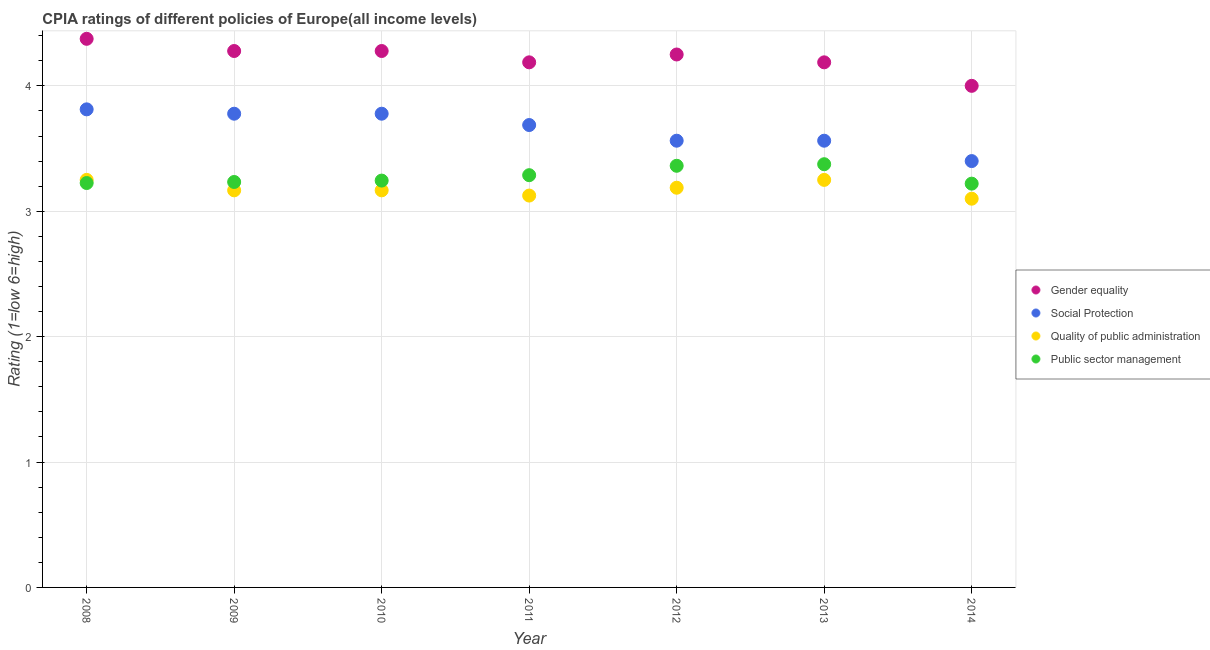How many different coloured dotlines are there?
Offer a very short reply. 4. Is the number of dotlines equal to the number of legend labels?
Offer a very short reply. Yes. What is the cpia rating of public sector management in 2008?
Keep it short and to the point. 3.23. What is the total cpia rating of quality of public administration in the graph?
Offer a terse response. 22.25. What is the difference between the cpia rating of social protection in 2010 and that in 2014?
Ensure brevity in your answer.  0.38. What is the difference between the cpia rating of public sector management in 2011 and the cpia rating of quality of public administration in 2014?
Keep it short and to the point. 0.19. What is the average cpia rating of gender equality per year?
Make the answer very short. 4.22. What is the ratio of the cpia rating of gender equality in 2008 to that in 2013?
Keep it short and to the point. 1.04. What is the difference between the highest and the second highest cpia rating of gender equality?
Ensure brevity in your answer.  0.1. What is the difference between the highest and the lowest cpia rating of quality of public administration?
Ensure brevity in your answer.  0.15. Is it the case that in every year, the sum of the cpia rating of quality of public administration and cpia rating of public sector management is greater than the sum of cpia rating of social protection and cpia rating of gender equality?
Keep it short and to the point. No. Does the cpia rating of social protection monotonically increase over the years?
Offer a very short reply. No. Is the cpia rating of public sector management strictly greater than the cpia rating of gender equality over the years?
Your answer should be very brief. No. How many dotlines are there?
Offer a very short reply. 4. What is the difference between two consecutive major ticks on the Y-axis?
Provide a short and direct response. 1. How many legend labels are there?
Give a very brief answer. 4. How are the legend labels stacked?
Your answer should be compact. Vertical. What is the title of the graph?
Offer a terse response. CPIA ratings of different policies of Europe(all income levels). Does "Corruption" appear as one of the legend labels in the graph?
Provide a short and direct response. No. What is the label or title of the Y-axis?
Give a very brief answer. Rating (1=low 6=high). What is the Rating (1=low 6=high) in Gender equality in 2008?
Your response must be concise. 4.38. What is the Rating (1=low 6=high) in Social Protection in 2008?
Your answer should be compact. 3.81. What is the Rating (1=low 6=high) of Public sector management in 2008?
Your response must be concise. 3.23. What is the Rating (1=low 6=high) of Gender equality in 2009?
Offer a very short reply. 4.28. What is the Rating (1=low 6=high) in Social Protection in 2009?
Provide a short and direct response. 3.78. What is the Rating (1=low 6=high) in Quality of public administration in 2009?
Your response must be concise. 3.17. What is the Rating (1=low 6=high) in Public sector management in 2009?
Your answer should be very brief. 3.23. What is the Rating (1=low 6=high) of Gender equality in 2010?
Offer a very short reply. 4.28. What is the Rating (1=low 6=high) in Social Protection in 2010?
Offer a very short reply. 3.78. What is the Rating (1=low 6=high) in Quality of public administration in 2010?
Give a very brief answer. 3.17. What is the Rating (1=low 6=high) of Public sector management in 2010?
Keep it short and to the point. 3.24. What is the Rating (1=low 6=high) in Gender equality in 2011?
Make the answer very short. 4.19. What is the Rating (1=low 6=high) in Social Protection in 2011?
Your response must be concise. 3.69. What is the Rating (1=low 6=high) in Quality of public administration in 2011?
Your answer should be compact. 3.12. What is the Rating (1=low 6=high) in Public sector management in 2011?
Make the answer very short. 3.29. What is the Rating (1=low 6=high) of Gender equality in 2012?
Give a very brief answer. 4.25. What is the Rating (1=low 6=high) in Social Protection in 2012?
Give a very brief answer. 3.56. What is the Rating (1=low 6=high) of Quality of public administration in 2012?
Your response must be concise. 3.19. What is the Rating (1=low 6=high) in Public sector management in 2012?
Keep it short and to the point. 3.36. What is the Rating (1=low 6=high) of Gender equality in 2013?
Your answer should be compact. 4.19. What is the Rating (1=low 6=high) of Social Protection in 2013?
Your answer should be compact. 3.56. What is the Rating (1=low 6=high) of Public sector management in 2013?
Your answer should be compact. 3.38. What is the Rating (1=low 6=high) of Gender equality in 2014?
Your response must be concise. 4. What is the Rating (1=low 6=high) of Social Protection in 2014?
Provide a short and direct response. 3.4. What is the Rating (1=low 6=high) of Quality of public administration in 2014?
Provide a short and direct response. 3.1. What is the Rating (1=low 6=high) of Public sector management in 2014?
Provide a short and direct response. 3.22. Across all years, what is the maximum Rating (1=low 6=high) of Gender equality?
Ensure brevity in your answer.  4.38. Across all years, what is the maximum Rating (1=low 6=high) of Social Protection?
Your answer should be compact. 3.81. Across all years, what is the maximum Rating (1=low 6=high) in Public sector management?
Ensure brevity in your answer.  3.38. Across all years, what is the minimum Rating (1=low 6=high) in Gender equality?
Make the answer very short. 4. Across all years, what is the minimum Rating (1=low 6=high) in Social Protection?
Give a very brief answer. 3.4. Across all years, what is the minimum Rating (1=low 6=high) in Public sector management?
Offer a very short reply. 3.22. What is the total Rating (1=low 6=high) in Gender equality in the graph?
Give a very brief answer. 29.56. What is the total Rating (1=low 6=high) of Social Protection in the graph?
Your response must be concise. 25.58. What is the total Rating (1=low 6=high) in Quality of public administration in the graph?
Your answer should be compact. 22.25. What is the total Rating (1=low 6=high) in Public sector management in the graph?
Your response must be concise. 22.95. What is the difference between the Rating (1=low 6=high) of Gender equality in 2008 and that in 2009?
Offer a very short reply. 0.1. What is the difference between the Rating (1=low 6=high) of Social Protection in 2008 and that in 2009?
Provide a succinct answer. 0.03. What is the difference between the Rating (1=low 6=high) of Quality of public administration in 2008 and that in 2009?
Give a very brief answer. 0.08. What is the difference between the Rating (1=low 6=high) in Public sector management in 2008 and that in 2009?
Keep it short and to the point. -0.01. What is the difference between the Rating (1=low 6=high) in Gender equality in 2008 and that in 2010?
Offer a very short reply. 0.1. What is the difference between the Rating (1=low 6=high) of Social Protection in 2008 and that in 2010?
Offer a terse response. 0.03. What is the difference between the Rating (1=low 6=high) of Quality of public administration in 2008 and that in 2010?
Your answer should be very brief. 0.08. What is the difference between the Rating (1=low 6=high) in Public sector management in 2008 and that in 2010?
Make the answer very short. -0.02. What is the difference between the Rating (1=low 6=high) in Gender equality in 2008 and that in 2011?
Your answer should be compact. 0.19. What is the difference between the Rating (1=low 6=high) of Social Protection in 2008 and that in 2011?
Your answer should be very brief. 0.12. What is the difference between the Rating (1=low 6=high) in Public sector management in 2008 and that in 2011?
Make the answer very short. -0.06. What is the difference between the Rating (1=low 6=high) of Gender equality in 2008 and that in 2012?
Provide a succinct answer. 0.12. What is the difference between the Rating (1=low 6=high) in Quality of public administration in 2008 and that in 2012?
Provide a succinct answer. 0.06. What is the difference between the Rating (1=low 6=high) in Public sector management in 2008 and that in 2012?
Offer a very short reply. -0.14. What is the difference between the Rating (1=low 6=high) of Gender equality in 2008 and that in 2013?
Give a very brief answer. 0.19. What is the difference between the Rating (1=low 6=high) of Social Protection in 2008 and that in 2013?
Keep it short and to the point. 0.25. What is the difference between the Rating (1=low 6=high) in Public sector management in 2008 and that in 2013?
Your answer should be compact. -0.15. What is the difference between the Rating (1=low 6=high) in Social Protection in 2008 and that in 2014?
Your response must be concise. 0.41. What is the difference between the Rating (1=low 6=high) in Public sector management in 2008 and that in 2014?
Your answer should be compact. 0.01. What is the difference between the Rating (1=low 6=high) in Gender equality in 2009 and that in 2010?
Give a very brief answer. 0. What is the difference between the Rating (1=low 6=high) of Social Protection in 2009 and that in 2010?
Offer a very short reply. 0. What is the difference between the Rating (1=low 6=high) of Public sector management in 2009 and that in 2010?
Offer a very short reply. -0.01. What is the difference between the Rating (1=low 6=high) of Gender equality in 2009 and that in 2011?
Provide a succinct answer. 0.09. What is the difference between the Rating (1=low 6=high) of Social Protection in 2009 and that in 2011?
Ensure brevity in your answer.  0.09. What is the difference between the Rating (1=low 6=high) in Quality of public administration in 2009 and that in 2011?
Your answer should be very brief. 0.04. What is the difference between the Rating (1=low 6=high) of Public sector management in 2009 and that in 2011?
Make the answer very short. -0.05. What is the difference between the Rating (1=low 6=high) in Gender equality in 2009 and that in 2012?
Offer a terse response. 0.03. What is the difference between the Rating (1=low 6=high) in Social Protection in 2009 and that in 2012?
Keep it short and to the point. 0.22. What is the difference between the Rating (1=low 6=high) in Quality of public administration in 2009 and that in 2012?
Make the answer very short. -0.02. What is the difference between the Rating (1=low 6=high) in Public sector management in 2009 and that in 2012?
Provide a short and direct response. -0.13. What is the difference between the Rating (1=low 6=high) in Gender equality in 2009 and that in 2013?
Provide a succinct answer. 0.09. What is the difference between the Rating (1=low 6=high) of Social Protection in 2009 and that in 2013?
Offer a very short reply. 0.22. What is the difference between the Rating (1=low 6=high) of Quality of public administration in 2009 and that in 2013?
Give a very brief answer. -0.08. What is the difference between the Rating (1=low 6=high) in Public sector management in 2009 and that in 2013?
Offer a very short reply. -0.14. What is the difference between the Rating (1=low 6=high) of Gender equality in 2009 and that in 2014?
Your answer should be very brief. 0.28. What is the difference between the Rating (1=low 6=high) in Social Protection in 2009 and that in 2014?
Offer a very short reply. 0.38. What is the difference between the Rating (1=low 6=high) of Quality of public administration in 2009 and that in 2014?
Offer a terse response. 0.07. What is the difference between the Rating (1=low 6=high) in Public sector management in 2009 and that in 2014?
Make the answer very short. 0.01. What is the difference between the Rating (1=low 6=high) in Gender equality in 2010 and that in 2011?
Keep it short and to the point. 0.09. What is the difference between the Rating (1=low 6=high) of Social Protection in 2010 and that in 2011?
Your response must be concise. 0.09. What is the difference between the Rating (1=low 6=high) of Quality of public administration in 2010 and that in 2011?
Provide a short and direct response. 0.04. What is the difference between the Rating (1=low 6=high) of Public sector management in 2010 and that in 2011?
Make the answer very short. -0.04. What is the difference between the Rating (1=low 6=high) of Gender equality in 2010 and that in 2012?
Give a very brief answer. 0.03. What is the difference between the Rating (1=low 6=high) of Social Protection in 2010 and that in 2012?
Offer a terse response. 0.22. What is the difference between the Rating (1=low 6=high) in Quality of public administration in 2010 and that in 2012?
Keep it short and to the point. -0.02. What is the difference between the Rating (1=low 6=high) in Public sector management in 2010 and that in 2012?
Provide a succinct answer. -0.12. What is the difference between the Rating (1=low 6=high) of Gender equality in 2010 and that in 2013?
Ensure brevity in your answer.  0.09. What is the difference between the Rating (1=low 6=high) of Social Protection in 2010 and that in 2013?
Provide a short and direct response. 0.22. What is the difference between the Rating (1=low 6=high) in Quality of public administration in 2010 and that in 2013?
Your answer should be compact. -0.08. What is the difference between the Rating (1=low 6=high) of Public sector management in 2010 and that in 2013?
Give a very brief answer. -0.13. What is the difference between the Rating (1=low 6=high) in Gender equality in 2010 and that in 2014?
Ensure brevity in your answer.  0.28. What is the difference between the Rating (1=low 6=high) in Social Protection in 2010 and that in 2014?
Give a very brief answer. 0.38. What is the difference between the Rating (1=low 6=high) in Quality of public administration in 2010 and that in 2014?
Offer a terse response. 0.07. What is the difference between the Rating (1=low 6=high) in Public sector management in 2010 and that in 2014?
Your answer should be compact. 0.02. What is the difference between the Rating (1=low 6=high) of Gender equality in 2011 and that in 2012?
Your answer should be compact. -0.06. What is the difference between the Rating (1=low 6=high) of Quality of public administration in 2011 and that in 2012?
Your answer should be very brief. -0.06. What is the difference between the Rating (1=low 6=high) in Public sector management in 2011 and that in 2012?
Offer a terse response. -0.07. What is the difference between the Rating (1=low 6=high) of Gender equality in 2011 and that in 2013?
Keep it short and to the point. 0. What is the difference between the Rating (1=low 6=high) in Social Protection in 2011 and that in 2013?
Offer a terse response. 0.12. What is the difference between the Rating (1=low 6=high) of Quality of public administration in 2011 and that in 2013?
Provide a succinct answer. -0.12. What is the difference between the Rating (1=low 6=high) in Public sector management in 2011 and that in 2013?
Provide a succinct answer. -0.09. What is the difference between the Rating (1=low 6=high) of Gender equality in 2011 and that in 2014?
Make the answer very short. 0.19. What is the difference between the Rating (1=low 6=high) of Social Protection in 2011 and that in 2014?
Your answer should be very brief. 0.29. What is the difference between the Rating (1=low 6=high) in Quality of public administration in 2011 and that in 2014?
Offer a very short reply. 0.03. What is the difference between the Rating (1=low 6=high) in Public sector management in 2011 and that in 2014?
Keep it short and to the point. 0.07. What is the difference between the Rating (1=low 6=high) of Gender equality in 2012 and that in 2013?
Your answer should be compact. 0.06. What is the difference between the Rating (1=low 6=high) in Quality of public administration in 2012 and that in 2013?
Ensure brevity in your answer.  -0.06. What is the difference between the Rating (1=low 6=high) in Public sector management in 2012 and that in 2013?
Keep it short and to the point. -0.01. What is the difference between the Rating (1=low 6=high) in Social Protection in 2012 and that in 2014?
Provide a succinct answer. 0.16. What is the difference between the Rating (1=low 6=high) of Quality of public administration in 2012 and that in 2014?
Provide a succinct answer. 0.09. What is the difference between the Rating (1=low 6=high) of Public sector management in 2012 and that in 2014?
Ensure brevity in your answer.  0.14. What is the difference between the Rating (1=low 6=high) in Gender equality in 2013 and that in 2014?
Ensure brevity in your answer.  0.19. What is the difference between the Rating (1=low 6=high) in Social Protection in 2013 and that in 2014?
Your response must be concise. 0.16. What is the difference between the Rating (1=low 6=high) of Public sector management in 2013 and that in 2014?
Provide a short and direct response. 0.15. What is the difference between the Rating (1=low 6=high) in Gender equality in 2008 and the Rating (1=low 6=high) in Social Protection in 2009?
Offer a terse response. 0.6. What is the difference between the Rating (1=low 6=high) of Gender equality in 2008 and the Rating (1=low 6=high) of Quality of public administration in 2009?
Provide a succinct answer. 1.21. What is the difference between the Rating (1=low 6=high) in Gender equality in 2008 and the Rating (1=low 6=high) in Public sector management in 2009?
Make the answer very short. 1.14. What is the difference between the Rating (1=low 6=high) in Social Protection in 2008 and the Rating (1=low 6=high) in Quality of public administration in 2009?
Your answer should be very brief. 0.65. What is the difference between the Rating (1=low 6=high) of Social Protection in 2008 and the Rating (1=low 6=high) of Public sector management in 2009?
Offer a terse response. 0.58. What is the difference between the Rating (1=low 6=high) in Quality of public administration in 2008 and the Rating (1=low 6=high) in Public sector management in 2009?
Keep it short and to the point. 0.02. What is the difference between the Rating (1=low 6=high) of Gender equality in 2008 and the Rating (1=low 6=high) of Social Protection in 2010?
Your answer should be very brief. 0.6. What is the difference between the Rating (1=low 6=high) of Gender equality in 2008 and the Rating (1=low 6=high) of Quality of public administration in 2010?
Ensure brevity in your answer.  1.21. What is the difference between the Rating (1=low 6=high) in Gender equality in 2008 and the Rating (1=low 6=high) in Public sector management in 2010?
Provide a succinct answer. 1.13. What is the difference between the Rating (1=low 6=high) in Social Protection in 2008 and the Rating (1=low 6=high) in Quality of public administration in 2010?
Your answer should be compact. 0.65. What is the difference between the Rating (1=low 6=high) in Social Protection in 2008 and the Rating (1=low 6=high) in Public sector management in 2010?
Ensure brevity in your answer.  0.57. What is the difference between the Rating (1=low 6=high) in Quality of public administration in 2008 and the Rating (1=low 6=high) in Public sector management in 2010?
Offer a very short reply. 0.01. What is the difference between the Rating (1=low 6=high) of Gender equality in 2008 and the Rating (1=low 6=high) of Social Protection in 2011?
Your answer should be compact. 0.69. What is the difference between the Rating (1=low 6=high) in Gender equality in 2008 and the Rating (1=low 6=high) in Quality of public administration in 2011?
Provide a succinct answer. 1.25. What is the difference between the Rating (1=low 6=high) of Gender equality in 2008 and the Rating (1=low 6=high) of Public sector management in 2011?
Your response must be concise. 1.09. What is the difference between the Rating (1=low 6=high) in Social Protection in 2008 and the Rating (1=low 6=high) in Quality of public administration in 2011?
Make the answer very short. 0.69. What is the difference between the Rating (1=low 6=high) of Social Protection in 2008 and the Rating (1=low 6=high) of Public sector management in 2011?
Your response must be concise. 0.53. What is the difference between the Rating (1=low 6=high) in Quality of public administration in 2008 and the Rating (1=low 6=high) in Public sector management in 2011?
Keep it short and to the point. -0.04. What is the difference between the Rating (1=low 6=high) of Gender equality in 2008 and the Rating (1=low 6=high) of Social Protection in 2012?
Your response must be concise. 0.81. What is the difference between the Rating (1=low 6=high) of Gender equality in 2008 and the Rating (1=low 6=high) of Quality of public administration in 2012?
Provide a short and direct response. 1.19. What is the difference between the Rating (1=low 6=high) in Gender equality in 2008 and the Rating (1=low 6=high) in Public sector management in 2012?
Make the answer very short. 1.01. What is the difference between the Rating (1=low 6=high) of Social Protection in 2008 and the Rating (1=low 6=high) of Quality of public administration in 2012?
Offer a very short reply. 0.62. What is the difference between the Rating (1=low 6=high) of Social Protection in 2008 and the Rating (1=low 6=high) of Public sector management in 2012?
Offer a very short reply. 0.45. What is the difference between the Rating (1=low 6=high) of Quality of public administration in 2008 and the Rating (1=low 6=high) of Public sector management in 2012?
Make the answer very short. -0.11. What is the difference between the Rating (1=low 6=high) of Gender equality in 2008 and the Rating (1=low 6=high) of Social Protection in 2013?
Your answer should be very brief. 0.81. What is the difference between the Rating (1=low 6=high) of Gender equality in 2008 and the Rating (1=low 6=high) of Public sector management in 2013?
Offer a terse response. 1. What is the difference between the Rating (1=low 6=high) in Social Protection in 2008 and the Rating (1=low 6=high) in Quality of public administration in 2013?
Offer a terse response. 0.56. What is the difference between the Rating (1=low 6=high) of Social Protection in 2008 and the Rating (1=low 6=high) of Public sector management in 2013?
Offer a terse response. 0.44. What is the difference between the Rating (1=low 6=high) in Quality of public administration in 2008 and the Rating (1=low 6=high) in Public sector management in 2013?
Offer a terse response. -0.12. What is the difference between the Rating (1=low 6=high) in Gender equality in 2008 and the Rating (1=low 6=high) in Quality of public administration in 2014?
Make the answer very short. 1.27. What is the difference between the Rating (1=low 6=high) of Gender equality in 2008 and the Rating (1=low 6=high) of Public sector management in 2014?
Ensure brevity in your answer.  1.16. What is the difference between the Rating (1=low 6=high) of Social Protection in 2008 and the Rating (1=low 6=high) of Quality of public administration in 2014?
Your answer should be very brief. 0.71. What is the difference between the Rating (1=low 6=high) in Social Protection in 2008 and the Rating (1=low 6=high) in Public sector management in 2014?
Your answer should be compact. 0.59. What is the difference between the Rating (1=low 6=high) of Quality of public administration in 2008 and the Rating (1=low 6=high) of Public sector management in 2014?
Your answer should be very brief. 0.03. What is the difference between the Rating (1=low 6=high) of Gender equality in 2009 and the Rating (1=low 6=high) of Social Protection in 2010?
Offer a terse response. 0.5. What is the difference between the Rating (1=low 6=high) of Gender equality in 2009 and the Rating (1=low 6=high) of Quality of public administration in 2010?
Your answer should be compact. 1.11. What is the difference between the Rating (1=low 6=high) in Social Protection in 2009 and the Rating (1=low 6=high) in Quality of public administration in 2010?
Your response must be concise. 0.61. What is the difference between the Rating (1=low 6=high) of Social Protection in 2009 and the Rating (1=low 6=high) of Public sector management in 2010?
Provide a short and direct response. 0.53. What is the difference between the Rating (1=low 6=high) in Quality of public administration in 2009 and the Rating (1=low 6=high) in Public sector management in 2010?
Ensure brevity in your answer.  -0.08. What is the difference between the Rating (1=low 6=high) in Gender equality in 2009 and the Rating (1=low 6=high) in Social Protection in 2011?
Provide a short and direct response. 0.59. What is the difference between the Rating (1=low 6=high) in Gender equality in 2009 and the Rating (1=low 6=high) in Quality of public administration in 2011?
Offer a terse response. 1.15. What is the difference between the Rating (1=low 6=high) of Gender equality in 2009 and the Rating (1=low 6=high) of Public sector management in 2011?
Provide a short and direct response. 0.99. What is the difference between the Rating (1=low 6=high) in Social Protection in 2009 and the Rating (1=low 6=high) in Quality of public administration in 2011?
Your answer should be compact. 0.65. What is the difference between the Rating (1=low 6=high) in Social Protection in 2009 and the Rating (1=low 6=high) in Public sector management in 2011?
Ensure brevity in your answer.  0.49. What is the difference between the Rating (1=low 6=high) of Quality of public administration in 2009 and the Rating (1=low 6=high) of Public sector management in 2011?
Provide a succinct answer. -0.12. What is the difference between the Rating (1=low 6=high) of Gender equality in 2009 and the Rating (1=low 6=high) of Social Protection in 2012?
Provide a succinct answer. 0.72. What is the difference between the Rating (1=low 6=high) of Gender equality in 2009 and the Rating (1=low 6=high) of Quality of public administration in 2012?
Give a very brief answer. 1.09. What is the difference between the Rating (1=low 6=high) in Gender equality in 2009 and the Rating (1=low 6=high) in Public sector management in 2012?
Your answer should be very brief. 0.92. What is the difference between the Rating (1=low 6=high) in Social Protection in 2009 and the Rating (1=low 6=high) in Quality of public administration in 2012?
Ensure brevity in your answer.  0.59. What is the difference between the Rating (1=low 6=high) in Social Protection in 2009 and the Rating (1=low 6=high) in Public sector management in 2012?
Your answer should be compact. 0.42. What is the difference between the Rating (1=low 6=high) in Quality of public administration in 2009 and the Rating (1=low 6=high) in Public sector management in 2012?
Your response must be concise. -0.2. What is the difference between the Rating (1=low 6=high) of Gender equality in 2009 and the Rating (1=low 6=high) of Social Protection in 2013?
Your response must be concise. 0.72. What is the difference between the Rating (1=low 6=high) in Gender equality in 2009 and the Rating (1=low 6=high) in Quality of public administration in 2013?
Your answer should be very brief. 1.03. What is the difference between the Rating (1=low 6=high) of Gender equality in 2009 and the Rating (1=low 6=high) of Public sector management in 2013?
Your response must be concise. 0.9. What is the difference between the Rating (1=low 6=high) of Social Protection in 2009 and the Rating (1=low 6=high) of Quality of public administration in 2013?
Keep it short and to the point. 0.53. What is the difference between the Rating (1=low 6=high) in Social Protection in 2009 and the Rating (1=low 6=high) in Public sector management in 2013?
Give a very brief answer. 0.4. What is the difference between the Rating (1=low 6=high) in Quality of public administration in 2009 and the Rating (1=low 6=high) in Public sector management in 2013?
Keep it short and to the point. -0.21. What is the difference between the Rating (1=low 6=high) in Gender equality in 2009 and the Rating (1=low 6=high) in Social Protection in 2014?
Provide a short and direct response. 0.88. What is the difference between the Rating (1=low 6=high) of Gender equality in 2009 and the Rating (1=low 6=high) of Quality of public administration in 2014?
Your answer should be compact. 1.18. What is the difference between the Rating (1=low 6=high) in Gender equality in 2009 and the Rating (1=low 6=high) in Public sector management in 2014?
Keep it short and to the point. 1.06. What is the difference between the Rating (1=low 6=high) in Social Protection in 2009 and the Rating (1=low 6=high) in Quality of public administration in 2014?
Provide a succinct answer. 0.68. What is the difference between the Rating (1=low 6=high) of Social Protection in 2009 and the Rating (1=low 6=high) of Public sector management in 2014?
Your answer should be very brief. 0.56. What is the difference between the Rating (1=low 6=high) in Quality of public administration in 2009 and the Rating (1=low 6=high) in Public sector management in 2014?
Provide a short and direct response. -0.05. What is the difference between the Rating (1=low 6=high) in Gender equality in 2010 and the Rating (1=low 6=high) in Social Protection in 2011?
Your answer should be compact. 0.59. What is the difference between the Rating (1=low 6=high) of Gender equality in 2010 and the Rating (1=low 6=high) of Quality of public administration in 2011?
Ensure brevity in your answer.  1.15. What is the difference between the Rating (1=low 6=high) in Gender equality in 2010 and the Rating (1=low 6=high) in Public sector management in 2011?
Your answer should be compact. 0.99. What is the difference between the Rating (1=low 6=high) of Social Protection in 2010 and the Rating (1=low 6=high) of Quality of public administration in 2011?
Provide a succinct answer. 0.65. What is the difference between the Rating (1=low 6=high) of Social Protection in 2010 and the Rating (1=low 6=high) of Public sector management in 2011?
Your response must be concise. 0.49. What is the difference between the Rating (1=low 6=high) of Quality of public administration in 2010 and the Rating (1=low 6=high) of Public sector management in 2011?
Your response must be concise. -0.12. What is the difference between the Rating (1=low 6=high) in Gender equality in 2010 and the Rating (1=low 6=high) in Social Protection in 2012?
Your response must be concise. 0.72. What is the difference between the Rating (1=low 6=high) in Gender equality in 2010 and the Rating (1=low 6=high) in Quality of public administration in 2012?
Keep it short and to the point. 1.09. What is the difference between the Rating (1=low 6=high) of Gender equality in 2010 and the Rating (1=low 6=high) of Public sector management in 2012?
Make the answer very short. 0.92. What is the difference between the Rating (1=low 6=high) in Social Protection in 2010 and the Rating (1=low 6=high) in Quality of public administration in 2012?
Provide a succinct answer. 0.59. What is the difference between the Rating (1=low 6=high) of Social Protection in 2010 and the Rating (1=low 6=high) of Public sector management in 2012?
Your answer should be compact. 0.42. What is the difference between the Rating (1=low 6=high) of Quality of public administration in 2010 and the Rating (1=low 6=high) of Public sector management in 2012?
Your answer should be very brief. -0.2. What is the difference between the Rating (1=low 6=high) of Gender equality in 2010 and the Rating (1=low 6=high) of Social Protection in 2013?
Offer a very short reply. 0.72. What is the difference between the Rating (1=low 6=high) of Gender equality in 2010 and the Rating (1=low 6=high) of Quality of public administration in 2013?
Give a very brief answer. 1.03. What is the difference between the Rating (1=low 6=high) in Gender equality in 2010 and the Rating (1=low 6=high) in Public sector management in 2013?
Ensure brevity in your answer.  0.9. What is the difference between the Rating (1=low 6=high) of Social Protection in 2010 and the Rating (1=low 6=high) of Quality of public administration in 2013?
Offer a terse response. 0.53. What is the difference between the Rating (1=low 6=high) in Social Protection in 2010 and the Rating (1=low 6=high) in Public sector management in 2013?
Offer a terse response. 0.4. What is the difference between the Rating (1=low 6=high) of Quality of public administration in 2010 and the Rating (1=low 6=high) of Public sector management in 2013?
Ensure brevity in your answer.  -0.21. What is the difference between the Rating (1=low 6=high) in Gender equality in 2010 and the Rating (1=low 6=high) in Social Protection in 2014?
Provide a short and direct response. 0.88. What is the difference between the Rating (1=low 6=high) in Gender equality in 2010 and the Rating (1=low 6=high) in Quality of public administration in 2014?
Provide a short and direct response. 1.18. What is the difference between the Rating (1=low 6=high) in Gender equality in 2010 and the Rating (1=low 6=high) in Public sector management in 2014?
Provide a short and direct response. 1.06. What is the difference between the Rating (1=low 6=high) in Social Protection in 2010 and the Rating (1=low 6=high) in Quality of public administration in 2014?
Your response must be concise. 0.68. What is the difference between the Rating (1=low 6=high) in Social Protection in 2010 and the Rating (1=low 6=high) in Public sector management in 2014?
Your response must be concise. 0.56. What is the difference between the Rating (1=low 6=high) in Quality of public administration in 2010 and the Rating (1=low 6=high) in Public sector management in 2014?
Provide a short and direct response. -0.05. What is the difference between the Rating (1=low 6=high) of Gender equality in 2011 and the Rating (1=low 6=high) of Quality of public administration in 2012?
Give a very brief answer. 1. What is the difference between the Rating (1=low 6=high) of Gender equality in 2011 and the Rating (1=low 6=high) of Public sector management in 2012?
Your answer should be compact. 0.82. What is the difference between the Rating (1=low 6=high) in Social Protection in 2011 and the Rating (1=low 6=high) in Quality of public administration in 2012?
Give a very brief answer. 0.5. What is the difference between the Rating (1=low 6=high) of Social Protection in 2011 and the Rating (1=low 6=high) of Public sector management in 2012?
Your response must be concise. 0.33. What is the difference between the Rating (1=low 6=high) in Quality of public administration in 2011 and the Rating (1=low 6=high) in Public sector management in 2012?
Provide a succinct answer. -0.24. What is the difference between the Rating (1=low 6=high) of Gender equality in 2011 and the Rating (1=low 6=high) of Social Protection in 2013?
Provide a short and direct response. 0.62. What is the difference between the Rating (1=low 6=high) of Gender equality in 2011 and the Rating (1=low 6=high) of Public sector management in 2013?
Your answer should be very brief. 0.81. What is the difference between the Rating (1=low 6=high) of Social Protection in 2011 and the Rating (1=low 6=high) of Quality of public administration in 2013?
Provide a succinct answer. 0.44. What is the difference between the Rating (1=low 6=high) of Social Protection in 2011 and the Rating (1=low 6=high) of Public sector management in 2013?
Offer a terse response. 0.31. What is the difference between the Rating (1=low 6=high) in Gender equality in 2011 and the Rating (1=low 6=high) in Social Protection in 2014?
Give a very brief answer. 0.79. What is the difference between the Rating (1=low 6=high) of Gender equality in 2011 and the Rating (1=low 6=high) of Quality of public administration in 2014?
Give a very brief answer. 1.09. What is the difference between the Rating (1=low 6=high) in Gender equality in 2011 and the Rating (1=low 6=high) in Public sector management in 2014?
Ensure brevity in your answer.  0.97. What is the difference between the Rating (1=low 6=high) of Social Protection in 2011 and the Rating (1=low 6=high) of Quality of public administration in 2014?
Provide a short and direct response. 0.59. What is the difference between the Rating (1=low 6=high) in Social Protection in 2011 and the Rating (1=low 6=high) in Public sector management in 2014?
Keep it short and to the point. 0.47. What is the difference between the Rating (1=low 6=high) of Quality of public administration in 2011 and the Rating (1=low 6=high) of Public sector management in 2014?
Provide a succinct answer. -0.1. What is the difference between the Rating (1=low 6=high) of Gender equality in 2012 and the Rating (1=low 6=high) of Social Protection in 2013?
Provide a succinct answer. 0.69. What is the difference between the Rating (1=low 6=high) of Social Protection in 2012 and the Rating (1=low 6=high) of Quality of public administration in 2013?
Keep it short and to the point. 0.31. What is the difference between the Rating (1=low 6=high) of Social Protection in 2012 and the Rating (1=low 6=high) of Public sector management in 2013?
Your answer should be compact. 0.19. What is the difference between the Rating (1=low 6=high) in Quality of public administration in 2012 and the Rating (1=low 6=high) in Public sector management in 2013?
Your response must be concise. -0.19. What is the difference between the Rating (1=low 6=high) in Gender equality in 2012 and the Rating (1=low 6=high) in Social Protection in 2014?
Ensure brevity in your answer.  0.85. What is the difference between the Rating (1=low 6=high) in Gender equality in 2012 and the Rating (1=low 6=high) in Quality of public administration in 2014?
Your answer should be very brief. 1.15. What is the difference between the Rating (1=low 6=high) in Social Protection in 2012 and the Rating (1=low 6=high) in Quality of public administration in 2014?
Provide a succinct answer. 0.46. What is the difference between the Rating (1=low 6=high) in Social Protection in 2012 and the Rating (1=low 6=high) in Public sector management in 2014?
Your response must be concise. 0.34. What is the difference between the Rating (1=low 6=high) of Quality of public administration in 2012 and the Rating (1=low 6=high) of Public sector management in 2014?
Keep it short and to the point. -0.03. What is the difference between the Rating (1=low 6=high) of Gender equality in 2013 and the Rating (1=low 6=high) of Social Protection in 2014?
Offer a terse response. 0.79. What is the difference between the Rating (1=low 6=high) in Gender equality in 2013 and the Rating (1=low 6=high) in Quality of public administration in 2014?
Keep it short and to the point. 1.09. What is the difference between the Rating (1=low 6=high) of Gender equality in 2013 and the Rating (1=low 6=high) of Public sector management in 2014?
Give a very brief answer. 0.97. What is the difference between the Rating (1=low 6=high) of Social Protection in 2013 and the Rating (1=low 6=high) of Quality of public administration in 2014?
Your answer should be compact. 0.46. What is the difference between the Rating (1=low 6=high) in Social Protection in 2013 and the Rating (1=low 6=high) in Public sector management in 2014?
Ensure brevity in your answer.  0.34. What is the average Rating (1=low 6=high) of Gender equality per year?
Offer a terse response. 4.22. What is the average Rating (1=low 6=high) in Social Protection per year?
Make the answer very short. 3.65. What is the average Rating (1=low 6=high) in Quality of public administration per year?
Make the answer very short. 3.18. What is the average Rating (1=low 6=high) of Public sector management per year?
Keep it short and to the point. 3.28. In the year 2008, what is the difference between the Rating (1=low 6=high) of Gender equality and Rating (1=low 6=high) of Social Protection?
Provide a short and direct response. 0.56. In the year 2008, what is the difference between the Rating (1=low 6=high) in Gender equality and Rating (1=low 6=high) in Quality of public administration?
Offer a terse response. 1.12. In the year 2008, what is the difference between the Rating (1=low 6=high) of Gender equality and Rating (1=low 6=high) of Public sector management?
Make the answer very short. 1.15. In the year 2008, what is the difference between the Rating (1=low 6=high) of Social Protection and Rating (1=low 6=high) of Quality of public administration?
Provide a succinct answer. 0.56. In the year 2008, what is the difference between the Rating (1=low 6=high) of Social Protection and Rating (1=low 6=high) of Public sector management?
Offer a very short reply. 0.59. In the year 2008, what is the difference between the Rating (1=low 6=high) of Quality of public administration and Rating (1=low 6=high) of Public sector management?
Ensure brevity in your answer.  0.03. In the year 2009, what is the difference between the Rating (1=low 6=high) in Gender equality and Rating (1=low 6=high) in Social Protection?
Offer a terse response. 0.5. In the year 2009, what is the difference between the Rating (1=low 6=high) in Gender equality and Rating (1=low 6=high) in Public sector management?
Offer a terse response. 1.04. In the year 2009, what is the difference between the Rating (1=low 6=high) in Social Protection and Rating (1=low 6=high) in Quality of public administration?
Provide a short and direct response. 0.61. In the year 2009, what is the difference between the Rating (1=low 6=high) in Social Protection and Rating (1=low 6=high) in Public sector management?
Your response must be concise. 0.54. In the year 2009, what is the difference between the Rating (1=low 6=high) of Quality of public administration and Rating (1=low 6=high) of Public sector management?
Keep it short and to the point. -0.07. In the year 2010, what is the difference between the Rating (1=low 6=high) of Social Protection and Rating (1=low 6=high) of Quality of public administration?
Keep it short and to the point. 0.61. In the year 2010, what is the difference between the Rating (1=low 6=high) of Social Protection and Rating (1=low 6=high) of Public sector management?
Provide a short and direct response. 0.53. In the year 2010, what is the difference between the Rating (1=low 6=high) of Quality of public administration and Rating (1=low 6=high) of Public sector management?
Give a very brief answer. -0.08. In the year 2011, what is the difference between the Rating (1=low 6=high) in Social Protection and Rating (1=low 6=high) in Quality of public administration?
Your answer should be very brief. 0.56. In the year 2011, what is the difference between the Rating (1=low 6=high) of Social Protection and Rating (1=low 6=high) of Public sector management?
Your response must be concise. 0.4. In the year 2011, what is the difference between the Rating (1=low 6=high) of Quality of public administration and Rating (1=low 6=high) of Public sector management?
Make the answer very short. -0.16. In the year 2012, what is the difference between the Rating (1=low 6=high) in Gender equality and Rating (1=low 6=high) in Social Protection?
Ensure brevity in your answer.  0.69. In the year 2012, what is the difference between the Rating (1=low 6=high) of Gender equality and Rating (1=low 6=high) of Public sector management?
Provide a short and direct response. 0.89. In the year 2012, what is the difference between the Rating (1=low 6=high) of Quality of public administration and Rating (1=low 6=high) of Public sector management?
Your answer should be very brief. -0.17. In the year 2013, what is the difference between the Rating (1=low 6=high) of Gender equality and Rating (1=low 6=high) of Quality of public administration?
Keep it short and to the point. 0.94. In the year 2013, what is the difference between the Rating (1=low 6=high) in Gender equality and Rating (1=low 6=high) in Public sector management?
Provide a short and direct response. 0.81. In the year 2013, what is the difference between the Rating (1=low 6=high) of Social Protection and Rating (1=low 6=high) of Quality of public administration?
Offer a very short reply. 0.31. In the year 2013, what is the difference between the Rating (1=low 6=high) in Social Protection and Rating (1=low 6=high) in Public sector management?
Provide a succinct answer. 0.19. In the year 2013, what is the difference between the Rating (1=low 6=high) of Quality of public administration and Rating (1=low 6=high) of Public sector management?
Provide a short and direct response. -0.12. In the year 2014, what is the difference between the Rating (1=low 6=high) in Gender equality and Rating (1=low 6=high) in Social Protection?
Offer a terse response. 0.6. In the year 2014, what is the difference between the Rating (1=low 6=high) of Gender equality and Rating (1=low 6=high) of Public sector management?
Offer a very short reply. 0.78. In the year 2014, what is the difference between the Rating (1=low 6=high) of Social Protection and Rating (1=low 6=high) of Quality of public administration?
Your response must be concise. 0.3. In the year 2014, what is the difference between the Rating (1=low 6=high) in Social Protection and Rating (1=low 6=high) in Public sector management?
Your answer should be compact. 0.18. In the year 2014, what is the difference between the Rating (1=low 6=high) of Quality of public administration and Rating (1=low 6=high) of Public sector management?
Give a very brief answer. -0.12. What is the ratio of the Rating (1=low 6=high) of Gender equality in 2008 to that in 2009?
Your response must be concise. 1.02. What is the ratio of the Rating (1=low 6=high) in Social Protection in 2008 to that in 2009?
Ensure brevity in your answer.  1.01. What is the ratio of the Rating (1=low 6=high) of Quality of public administration in 2008 to that in 2009?
Make the answer very short. 1.03. What is the ratio of the Rating (1=low 6=high) of Public sector management in 2008 to that in 2009?
Offer a very short reply. 1. What is the ratio of the Rating (1=low 6=high) of Gender equality in 2008 to that in 2010?
Make the answer very short. 1.02. What is the ratio of the Rating (1=low 6=high) in Social Protection in 2008 to that in 2010?
Ensure brevity in your answer.  1.01. What is the ratio of the Rating (1=low 6=high) of Quality of public administration in 2008 to that in 2010?
Keep it short and to the point. 1.03. What is the ratio of the Rating (1=low 6=high) of Gender equality in 2008 to that in 2011?
Your answer should be compact. 1.04. What is the ratio of the Rating (1=low 6=high) in Social Protection in 2008 to that in 2011?
Your answer should be very brief. 1.03. What is the ratio of the Rating (1=low 6=high) in Gender equality in 2008 to that in 2012?
Keep it short and to the point. 1.03. What is the ratio of the Rating (1=low 6=high) in Social Protection in 2008 to that in 2012?
Ensure brevity in your answer.  1.07. What is the ratio of the Rating (1=low 6=high) of Quality of public administration in 2008 to that in 2012?
Provide a short and direct response. 1.02. What is the ratio of the Rating (1=low 6=high) in Public sector management in 2008 to that in 2012?
Provide a succinct answer. 0.96. What is the ratio of the Rating (1=low 6=high) of Gender equality in 2008 to that in 2013?
Your answer should be very brief. 1.04. What is the ratio of the Rating (1=low 6=high) in Social Protection in 2008 to that in 2013?
Make the answer very short. 1.07. What is the ratio of the Rating (1=low 6=high) in Public sector management in 2008 to that in 2013?
Your answer should be compact. 0.96. What is the ratio of the Rating (1=low 6=high) of Gender equality in 2008 to that in 2014?
Offer a terse response. 1.09. What is the ratio of the Rating (1=low 6=high) of Social Protection in 2008 to that in 2014?
Your answer should be very brief. 1.12. What is the ratio of the Rating (1=low 6=high) in Quality of public administration in 2008 to that in 2014?
Give a very brief answer. 1.05. What is the ratio of the Rating (1=low 6=high) of Public sector management in 2008 to that in 2014?
Offer a terse response. 1. What is the ratio of the Rating (1=low 6=high) of Social Protection in 2009 to that in 2010?
Ensure brevity in your answer.  1. What is the ratio of the Rating (1=low 6=high) of Public sector management in 2009 to that in 2010?
Offer a terse response. 1. What is the ratio of the Rating (1=low 6=high) of Gender equality in 2009 to that in 2011?
Offer a terse response. 1.02. What is the ratio of the Rating (1=low 6=high) in Social Protection in 2009 to that in 2011?
Provide a succinct answer. 1.02. What is the ratio of the Rating (1=low 6=high) of Quality of public administration in 2009 to that in 2011?
Keep it short and to the point. 1.01. What is the ratio of the Rating (1=low 6=high) in Public sector management in 2009 to that in 2011?
Ensure brevity in your answer.  0.98. What is the ratio of the Rating (1=low 6=high) of Gender equality in 2009 to that in 2012?
Your answer should be very brief. 1.01. What is the ratio of the Rating (1=low 6=high) in Social Protection in 2009 to that in 2012?
Offer a very short reply. 1.06. What is the ratio of the Rating (1=low 6=high) of Public sector management in 2009 to that in 2012?
Ensure brevity in your answer.  0.96. What is the ratio of the Rating (1=low 6=high) of Gender equality in 2009 to that in 2013?
Give a very brief answer. 1.02. What is the ratio of the Rating (1=low 6=high) in Social Protection in 2009 to that in 2013?
Make the answer very short. 1.06. What is the ratio of the Rating (1=low 6=high) in Quality of public administration in 2009 to that in 2013?
Your answer should be very brief. 0.97. What is the ratio of the Rating (1=low 6=high) in Public sector management in 2009 to that in 2013?
Ensure brevity in your answer.  0.96. What is the ratio of the Rating (1=low 6=high) in Gender equality in 2009 to that in 2014?
Offer a terse response. 1.07. What is the ratio of the Rating (1=low 6=high) in Quality of public administration in 2009 to that in 2014?
Make the answer very short. 1.02. What is the ratio of the Rating (1=low 6=high) in Gender equality in 2010 to that in 2011?
Offer a very short reply. 1.02. What is the ratio of the Rating (1=low 6=high) of Social Protection in 2010 to that in 2011?
Provide a succinct answer. 1.02. What is the ratio of the Rating (1=low 6=high) in Quality of public administration in 2010 to that in 2011?
Your response must be concise. 1.01. What is the ratio of the Rating (1=low 6=high) in Public sector management in 2010 to that in 2011?
Provide a succinct answer. 0.99. What is the ratio of the Rating (1=low 6=high) of Gender equality in 2010 to that in 2012?
Offer a terse response. 1.01. What is the ratio of the Rating (1=low 6=high) of Social Protection in 2010 to that in 2012?
Your answer should be compact. 1.06. What is the ratio of the Rating (1=low 6=high) of Public sector management in 2010 to that in 2012?
Give a very brief answer. 0.96. What is the ratio of the Rating (1=low 6=high) of Gender equality in 2010 to that in 2013?
Provide a succinct answer. 1.02. What is the ratio of the Rating (1=low 6=high) in Social Protection in 2010 to that in 2013?
Ensure brevity in your answer.  1.06. What is the ratio of the Rating (1=low 6=high) of Quality of public administration in 2010 to that in 2013?
Give a very brief answer. 0.97. What is the ratio of the Rating (1=low 6=high) in Public sector management in 2010 to that in 2013?
Your response must be concise. 0.96. What is the ratio of the Rating (1=low 6=high) of Gender equality in 2010 to that in 2014?
Your response must be concise. 1.07. What is the ratio of the Rating (1=low 6=high) of Social Protection in 2010 to that in 2014?
Provide a short and direct response. 1.11. What is the ratio of the Rating (1=low 6=high) in Quality of public administration in 2010 to that in 2014?
Your answer should be compact. 1.02. What is the ratio of the Rating (1=low 6=high) of Public sector management in 2010 to that in 2014?
Give a very brief answer. 1.01. What is the ratio of the Rating (1=low 6=high) of Gender equality in 2011 to that in 2012?
Provide a short and direct response. 0.99. What is the ratio of the Rating (1=low 6=high) of Social Protection in 2011 to that in 2012?
Your response must be concise. 1.04. What is the ratio of the Rating (1=low 6=high) in Quality of public administration in 2011 to that in 2012?
Provide a succinct answer. 0.98. What is the ratio of the Rating (1=low 6=high) of Public sector management in 2011 to that in 2012?
Keep it short and to the point. 0.98. What is the ratio of the Rating (1=low 6=high) of Social Protection in 2011 to that in 2013?
Offer a terse response. 1.04. What is the ratio of the Rating (1=low 6=high) of Quality of public administration in 2011 to that in 2013?
Ensure brevity in your answer.  0.96. What is the ratio of the Rating (1=low 6=high) in Public sector management in 2011 to that in 2013?
Ensure brevity in your answer.  0.97. What is the ratio of the Rating (1=low 6=high) of Gender equality in 2011 to that in 2014?
Give a very brief answer. 1.05. What is the ratio of the Rating (1=low 6=high) in Social Protection in 2011 to that in 2014?
Offer a very short reply. 1.08. What is the ratio of the Rating (1=low 6=high) in Quality of public administration in 2011 to that in 2014?
Your answer should be very brief. 1.01. What is the ratio of the Rating (1=low 6=high) of Public sector management in 2011 to that in 2014?
Give a very brief answer. 1.02. What is the ratio of the Rating (1=low 6=high) in Gender equality in 2012 to that in 2013?
Provide a succinct answer. 1.01. What is the ratio of the Rating (1=low 6=high) of Social Protection in 2012 to that in 2013?
Your response must be concise. 1. What is the ratio of the Rating (1=low 6=high) in Quality of public administration in 2012 to that in 2013?
Keep it short and to the point. 0.98. What is the ratio of the Rating (1=low 6=high) of Social Protection in 2012 to that in 2014?
Make the answer very short. 1.05. What is the ratio of the Rating (1=low 6=high) in Quality of public administration in 2012 to that in 2014?
Your answer should be compact. 1.03. What is the ratio of the Rating (1=low 6=high) of Public sector management in 2012 to that in 2014?
Give a very brief answer. 1.04. What is the ratio of the Rating (1=low 6=high) of Gender equality in 2013 to that in 2014?
Offer a very short reply. 1.05. What is the ratio of the Rating (1=low 6=high) of Social Protection in 2013 to that in 2014?
Keep it short and to the point. 1.05. What is the ratio of the Rating (1=low 6=high) of Quality of public administration in 2013 to that in 2014?
Keep it short and to the point. 1.05. What is the ratio of the Rating (1=low 6=high) of Public sector management in 2013 to that in 2014?
Provide a short and direct response. 1.05. What is the difference between the highest and the second highest Rating (1=low 6=high) of Gender equality?
Keep it short and to the point. 0.1. What is the difference between the highest and the second highest Rating (1=low 6=high) in Social Protection?
Offer a very short reply. 0.03. What is the difference between the highest and the second highest Rating (1=low 6=high) in Quality of public administration?
Your answer should be compact. 0. What is the difference between the highest and the second highest Rating (1=low 6=high) in Public sector management?
Offer a very short reply. 0.01. What is the difference between the highest and the lowest Rating (1=low 6=high) in Gender equality?
Make the answer very short. 0.38. What is the difference between the highest and the lowest Rating (1=low 6=high) of Social Protection?
Your response must be concise. 0.41. What is the difference between the highest and the lowest Rating (1=low 6=high) in Quality of public administration?
Your answer should be very brief. 0.15. What is the difference between the highest and the lowest Rating (1=low 6=high) in Public sector management?
Provide a short and direct response. 0.15. 